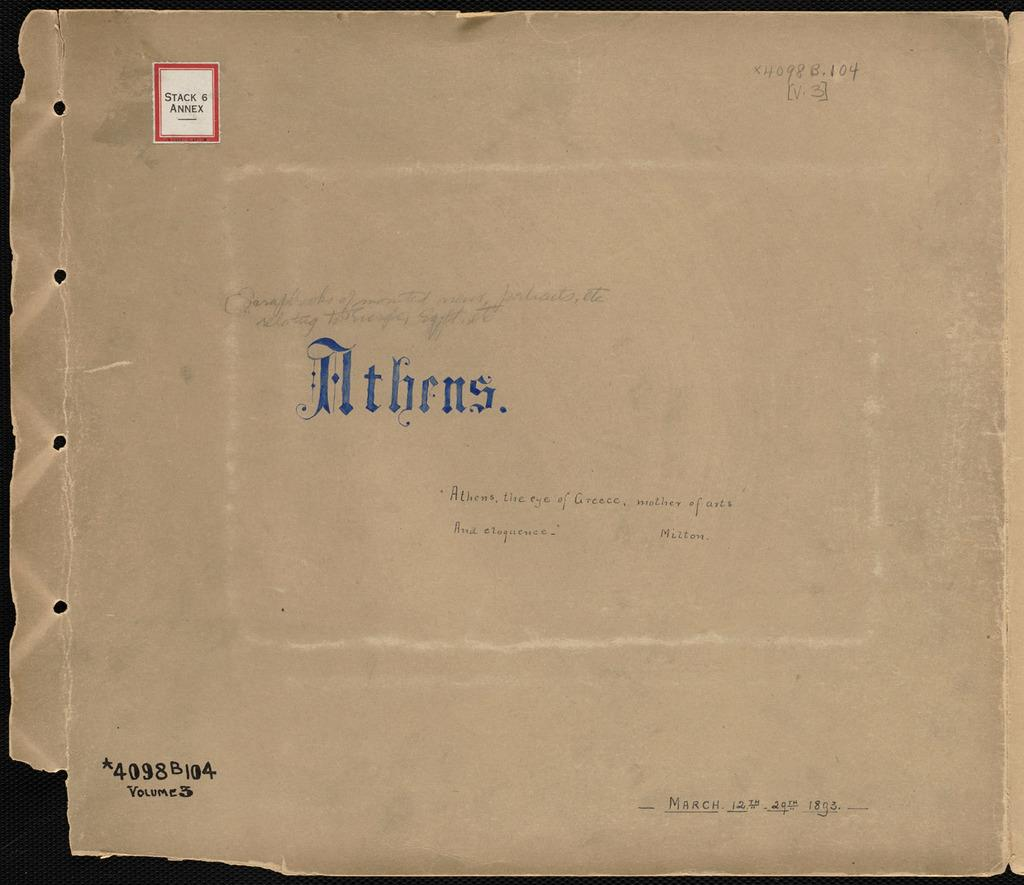<image>
Describe the image concisely. An old paper on Athens that is stored in Stack 6 of an Annex library 